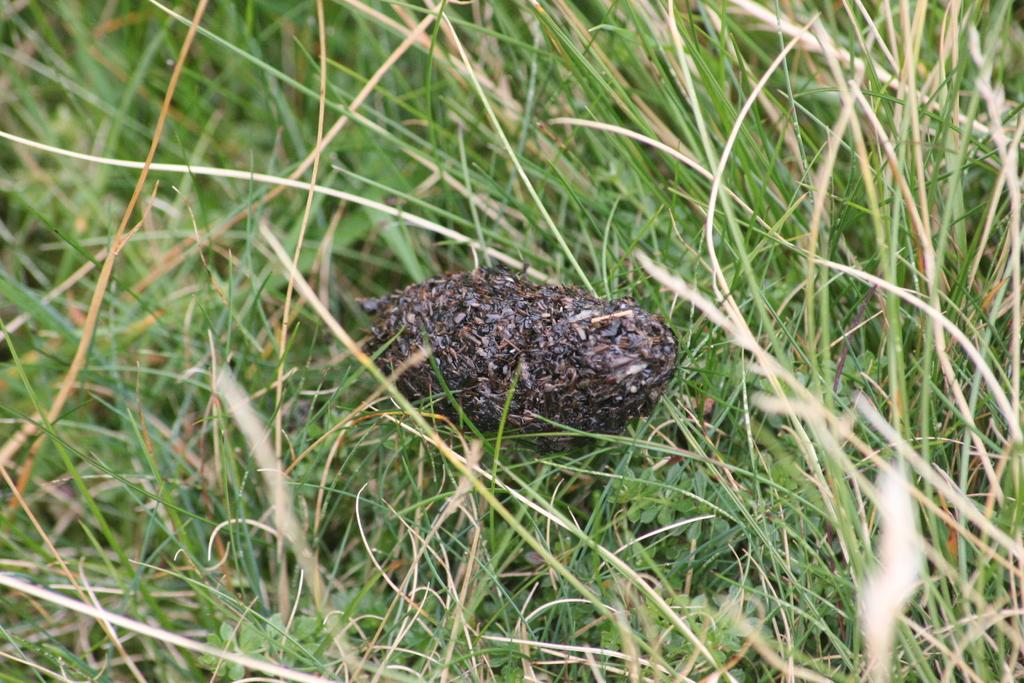What is located in the center of the image? There is a stock of insects in the center of the image. What type of natural environment is visible in the background of the image? There is grass visible in the background of the image. Where is the camera placed in the image? There is no camera present in the image. What type of furniture is visible in the image? There is no furniture, such as a sofa, present in the image. 